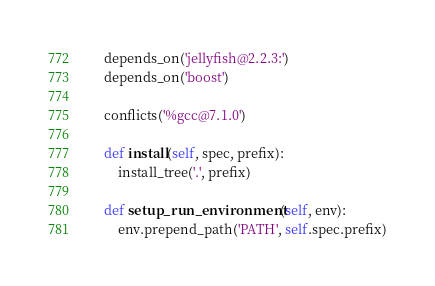<code> <loc_0><loc_0><loc_500><loc_500><_Python_>
    depends_on('jellyfish@2.2.3:')
    depends_on('boost')

    conflicts('%gcc@7.1.0')

    def install(self, spec, prefix):
        install_tree('.', prefix)

    def setup_run_environment(self, env):
        env.prepend_path('PATH', self.spec.prefix)
</code> 